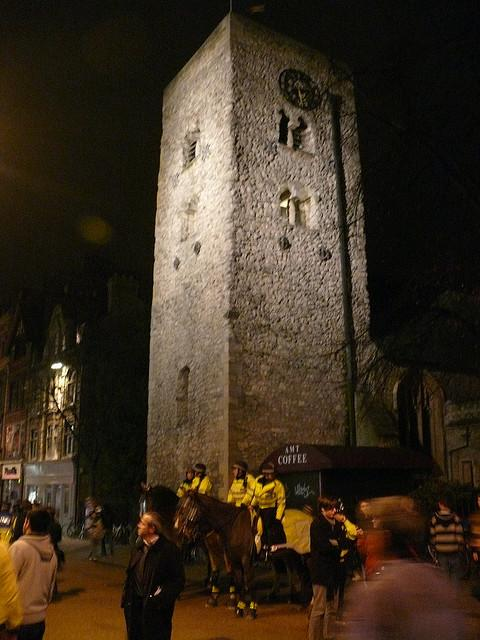What material composes this old square tower? Please explain your reasoning. cobblestone. This is an old stone tower. 